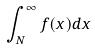<formula> <loc_0><loc_0><loc_500><loc_500>\int _ { N } ^ { \infty } f ( x ) d x</formula> 